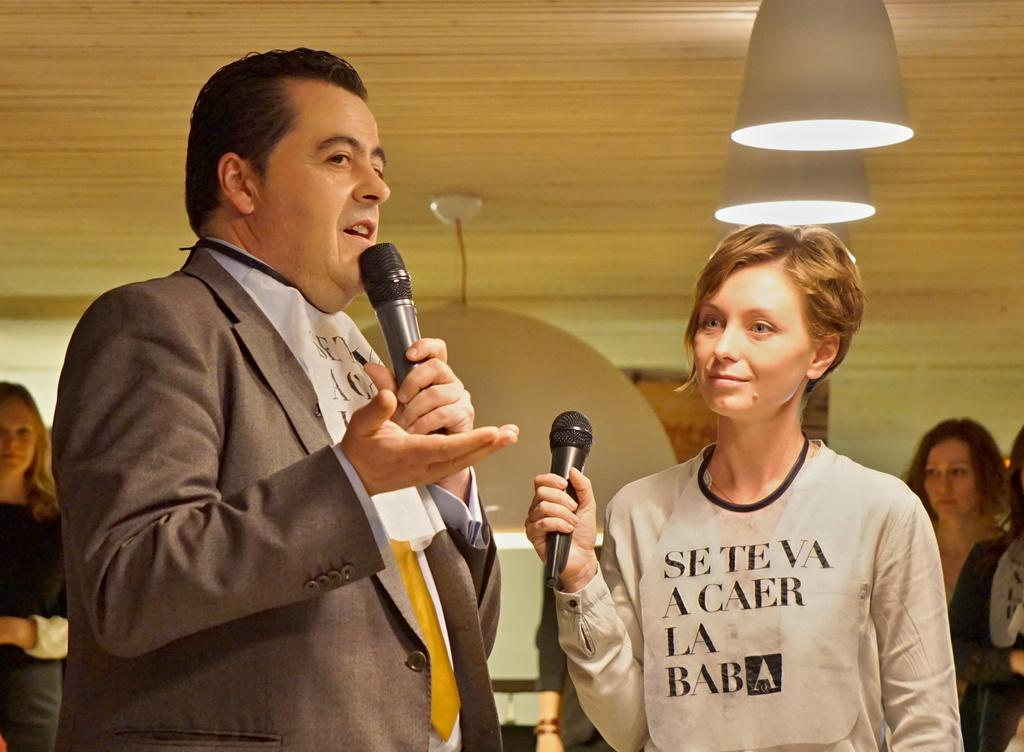What is the person in the image doing? The person is talking on a mic. Who else is holding a mic in the image? There is a woman holding a mic in the image. Can you describe the people visible in the image? There are other people visible in the image, but their actions are not specified. What is the background of the image? There is a wall in the image. What can be seen illuminated in the image? There are lights in the image. Where is the library located in the image? There is no library present in the image. How many rabbits can be seen in the image? There are no rabbits present in the image. 